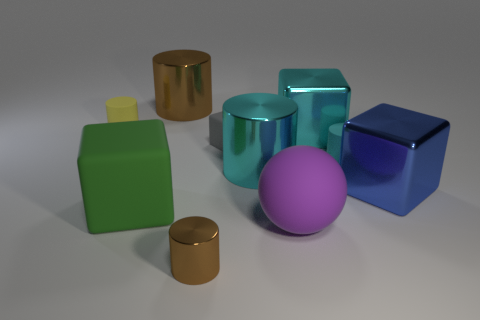What is the shape of the large green object that is made of the same material as the small cyan cylinder?
Give a very brief answer. Cube. The cyan cylinder in front of the small matte cylinder that is in front of the cyan thing behind the gray rubber cube is made of what material?
Provide a short and direct response. Metal. How many objects are either small matte cylinders to the left of the large brown object or small blue rubber things?
Offer a terse response. 1. What number of other things are there of the same shape as the large brown shiny object?
Provide a short and direct response. 4. Is the number of metallic cubes that are behind the blue block greater than the number of large green metallic cubes?
Provide a short and direct response. Yes. The yellow matte thing that is the same shape as the tiny metal object is what size?
Your answer should be very brief. Small. The small brown metal thing has what shape?
Keep it short and to the point. Cylinder. There is a shiny thing that is the same size as the yellow matte cylinder; what is its shape?
Your response must be concise. Cylinder. Are there any other things that are the same color as the small block?
Offer a terse response. No. What is the size of the yellow cylinder that is the same material as the small gray cube?
Offer a terse response. Small. 